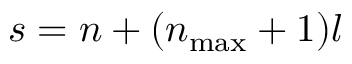<formula> <loc_0><loc_0><loc_500><loc_500>s = n + ( n _ { \max } + 1 ) l</formula> 